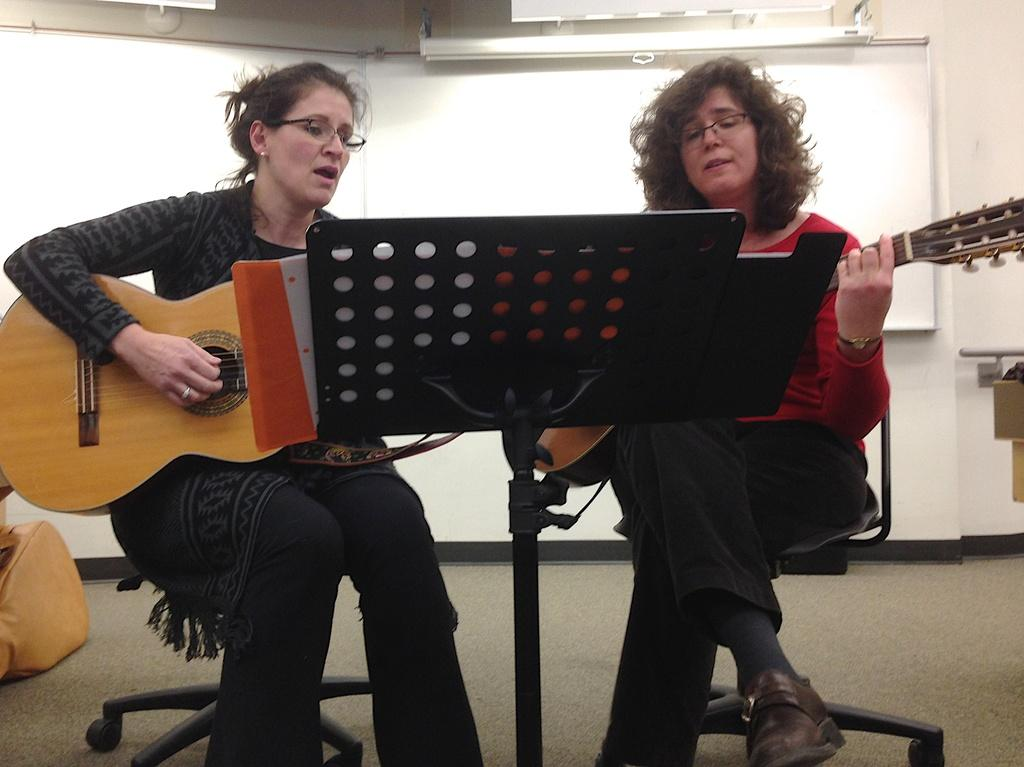How many people are in the image? There are two men in the image. What are the men doing in the image? The men are seated on chairs, and one of them is playing a guitar. What object is present in front of the men? There is a book stand in front of the men. What is located behind the men in the image? There is a whiteboard behind the men. What type of thread is being used by the men to play the guitar in the image? There is no thread being used by the men to play the guitar in the image; the guitar is being played with the man's fingers. 